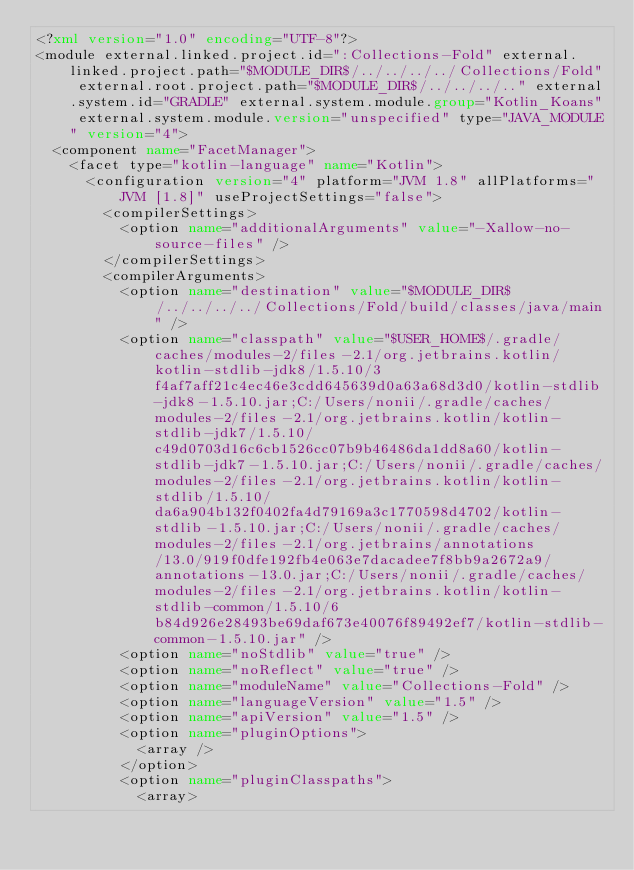<code> <loc_0><loc_0><loc_500><loc_500><_XML_><?xml version="1.0" encoding="UTF-8"?>
<module external.linked.project.id=":Collections-Fold" external.linked.project.path="$MODULE_DIR$/../../../../Collections/Fold" external.root.project.path="$MODULE_DIR$/../../../.." external.system.id="GRADLE" external.system.module.group="Kotlin_Koans" external.system.module.version="unspecified" type="JAVA_MODULE" version="4">
  <component name="FacetManager">
    <facet type="kotlin-language" name="Kotlin">
      <configuration version="4" platform="JVM 1.8" allPlatforms="JVM [1.8]" useProjectSettings="false">
        <compilerSettings>
          <option name="additionalArguments" value="-Xallow-no-source-files" />
        </compilerSettings>
        <compilerArguments>
          <option name="destination" value="$MODULE_DIR$/../../../../Collections/Fold/build/classes/java/main" />
          <option name="classpath" value="$USER_HOME$/.gradle/caches/modules-2/files-2.1/org.jetbrains.kotlin/kotlin-stdlib-jdk8/1.5.10/3f4af7aff21c4ec46e3cdd645639d0a63a68d3d0/kotlin-stdlib-jdk8-1.5.10.jar;C:/Users/nonii/.gradle/caches/modules-2/files-2.1/org.jetbrains.kotlin/kotlin-stdlib-jdk7/1.5.10/c49d0703d16c6cb1526cc07b9b46486da1dd8a60/kotlin-stdlib-jdk7-1.5.10.jar;C:/Users/nonii/.gradle/caches/modules-2/files-2.1/org.jetbrains.kotlin/kotlin-stdlib/1.5.10/da6a904b132f0402fa4d79169a3c1770598d4702/kotlin-stdlib-1.5.10.jar;C:/Users/nonii/.gradle/caches/modules-2/files-2.1/org.jetbrains/annotations/13.0/919f0dfe192fb4e063e7dacadee7f8bb9a2672a9/annotations-13.0.jar;C:/Users/nonii/.gradle/caches/modules-2/files-2.1/org.jetbrains.kotlin/kotlin-stdlib-common/1.5.10/6b84d926e28493be69daf673e40076f89492ef7/kotlin-stdlib-common-1.5.10.jar" />
          <option name="noStdlib" value="true" />
          <option name="noReflect" value="true" />
          <option name="moduleName" value="Collections-Fold" />
          <option name="languageVersion" value="1.5" />
          <option name="apiVersion" value="1.5" />
          <option name="pluginOptions">
            <array />
          </option>
          <option name="pluginClasspaths">
            <array></code> 